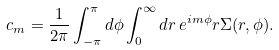<formula> <loc_0><loc_0><loc_500><loc_500>c _ { m } = \frac { 1 } { 2 \pi } \int _ { - \pi } ^ { \pi } d \phi \int _ { 0 } ^ { \infty } d r \, e ^ { i m \phi } r \Sigma ( r , \phi ) .</formula> 